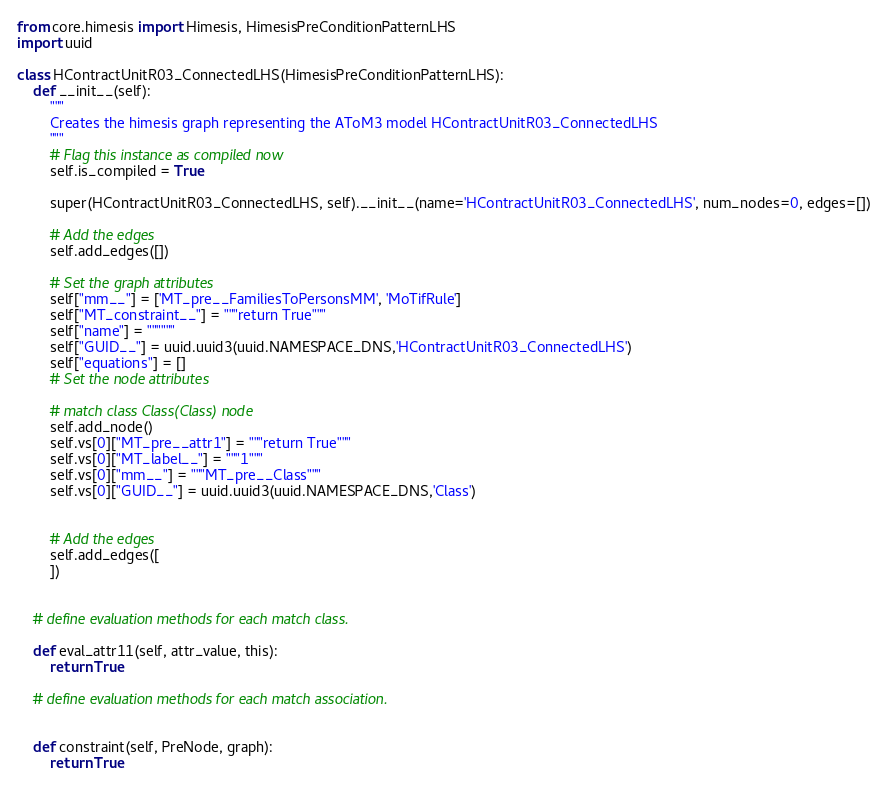Convert code to text. <code><loc_0><loc_0><loc_500><loc_500><_Python_>from core.himesis import Himesis, HimesisPreConditionPatternLHS
import uuid

class HContractUnitR03_ConnectedLHS(HimesisPreConditionPatternLHS):
	def __init__(self):
		"""
		Creates the himesis graph representing the AToM3 model HContractUnitR03_ConnectedLHS
		"""
		# Flag this instance as compiled now
		self.is_compiled = True

		super(HContractUnitR03_ConnectedLHS, self).__init__(name='HContractUnitR03_ConnectedLHS', num_nodes=0, edges=[])

		# Add the edges
		self.add_edges([])

		# Set the graph attributes
		self["mm__"] = ['MT_pre__FamiliesToPersonsMM', 'MoTifRule']
		self["MT_constraint__"] = """return True"""
		self["name"] = """"""
		self["GUID__"] = uuid.uuid3(uuid.NAMESPACE_DNS,'HContractUnitR03_ConnectedLHS')
		self["equations"] = []
		# Set the node attributes

		# match class Class(Class) node
		self.add_node()
		self.vs[0]["MT_pre__attr1"] = """return True"""
		self.vs[0]["MT_label__"] = """1"""
		self.vs[0]["mm__"] = """MT_pre__Class"""
		self.vs[0]["GUID__"] = uuid.uuid3(uuid.NAMESPACE_DNS,'Class')


		# Add the edges
		self.add_edges([
		])


	# define evaluation methods for each match class.

	def eval_attr11(self, attr_value, this):
		return True

	# define evaluation methods for each match association.


	def constraint(self, PreNode, graph):
		return True

</code> 